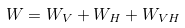Convert formula to latex. <formula><loc_0><loc_0><loc_500><loc_500>W = W _ { V } + W _ { H } + W _ { V H }</formula> 